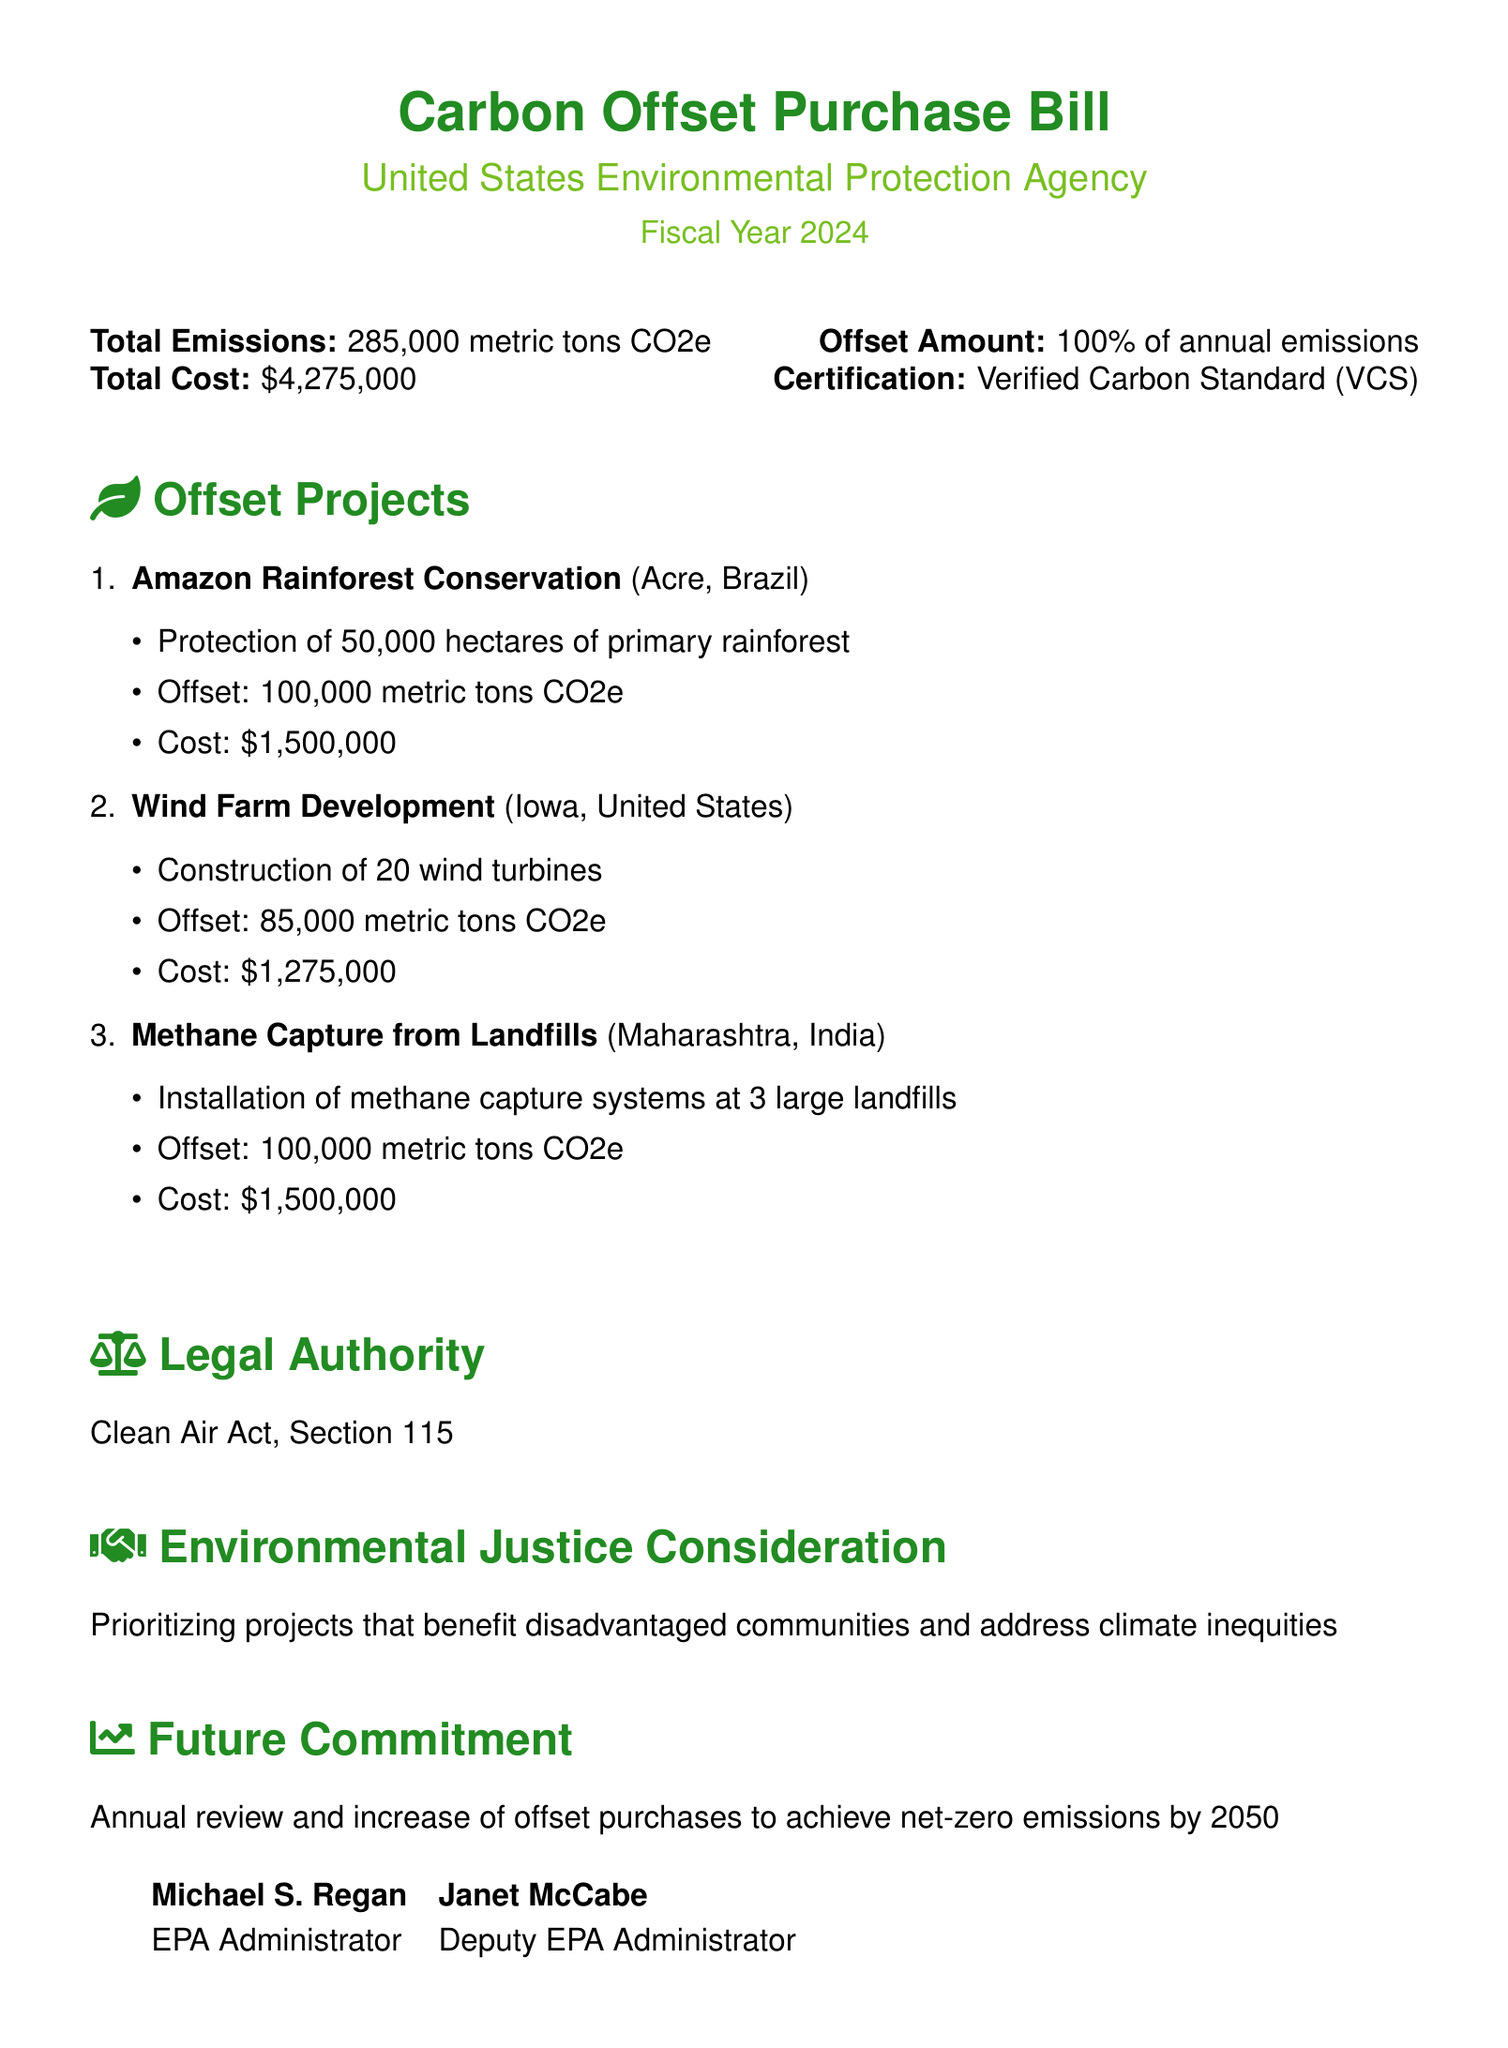what is the total emissions? The total emissions listed in the document are 285,000 metric tons CO2e.
Answer: 285,000 metric tons CO2e what is the offset amount? The offset amount is stated to be 100% of annual emissions.
Answer: 100% of annual emissions how much does the carbon offset purchase cost? The total cost for the carbon offset purchase is provided in the document as $4,275,000.
Answer: $4,275,000 which certification is used for the offsets? The certification for the offsets mentioned is the Verified Carbon Standard (VCS).
Answer: Verified Carbon Standard (VCS) how many wind turbines are included in the Wind Farm Development project? The Wind Farm Development project includes the construction of 20 wind turbines.
Answer: 20 wind turbines what is the offset from the Amazon Rainforest Conservation project? The offset from the Amazon Rainforest Conservation project is 100,000 metric tons CO2e.
Answer: 100,000 metric tons CO2e which legal authority is cited for this bill? The legal authority cited in the document is the Clean Air Act, Section 115.
Answer: Clean Air Act, Section 115 what is the future commitment mentioned in the bill? The future commitment mentioned is an annual review and increase of offset purchases to achieve net-zero emissions by 2050.
Answer: net-zero emissions by 2050 what is the main consideration for environmental justice in these projects? The main consideration is prioritizing projects that benefit disadvantaged communities.
Answer: disadvantaged communities 